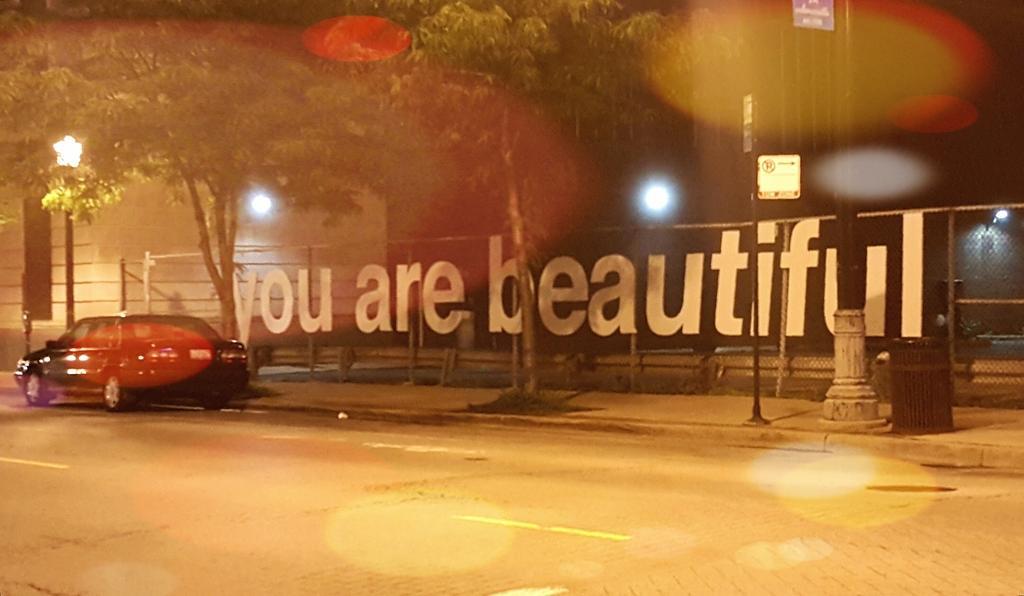How would you summarize this image in a sentence or two? In the middle of the image we can see a vehicle on the road. At the top of the image we can see some trees and poles. Behind them we can see fencing and buildings. Background of the image is blur. 